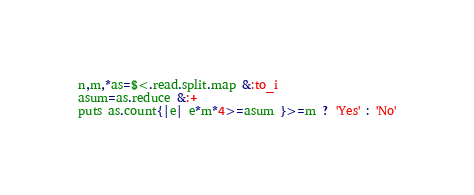Convert code to text. <code><loc_0><loc_0><loc_500><loc_500><_Ruby_>n,m,*as=$<.read.split.map &:to_i
asum=as.reduce &:+
puts as.count{|e| e*m*4>=asum }>=m ? 'Yes' : 'No'</code> 